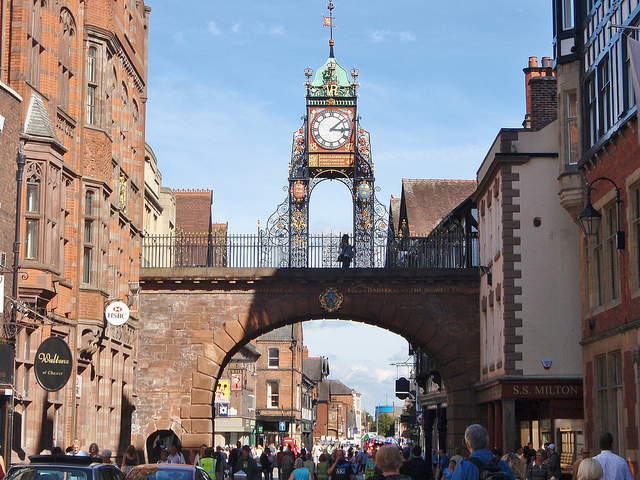Read all the text in this image. S.S. MILTON MR II II II g 